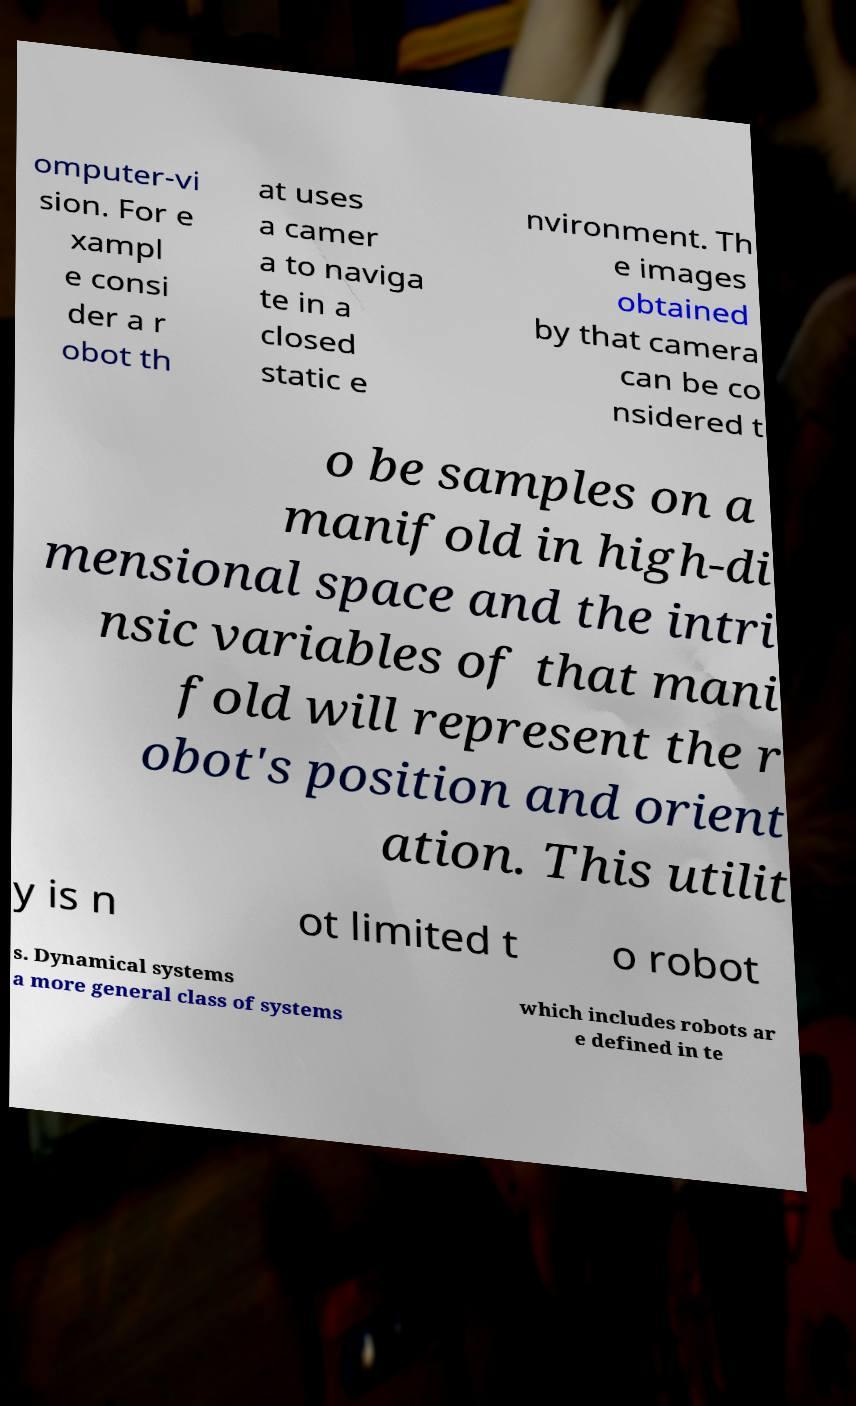Please identify and transcribe the text found in this image. omputer-vi sion. For e xampl e consi der a r obot th at uses a camer a to naviga te in a closed static e nvironment. Th e images obtained by that camera can be co nsidered t o be samples on a manifold in high-di mensional space and the intri nsic variables of that mani fold will represent the r obot's position and orient ation. This utilit y is n ot limited t o robot s. Dynamical systems a more general class of systems which includes robots ar e defined in te 